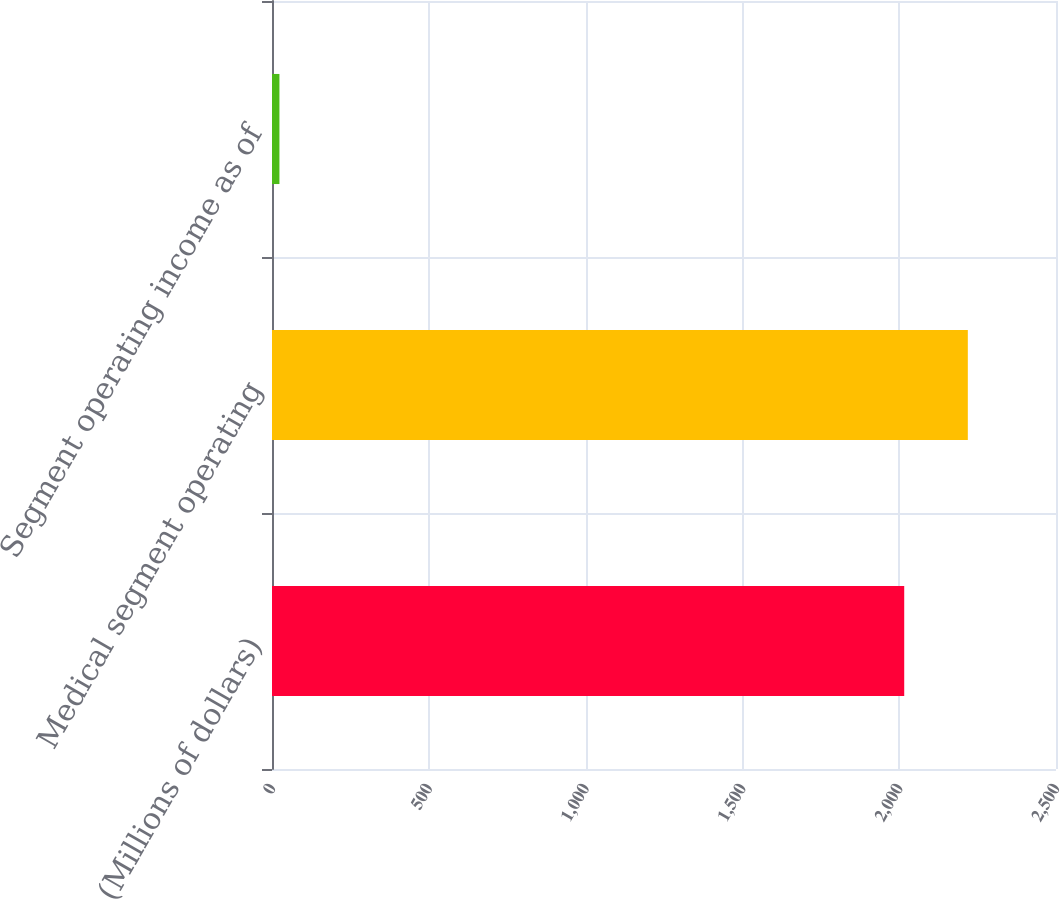Convert chart. <chart><loc_0><loc_0><loc_500><loc_500><bar_chart><fcel>(Millions of dollars)<fcel>Medical segment operating<fcel>Segment operating income as of<nl><fcel>2016<fcel>2218.83<fcel>23.7<nl></chart> 